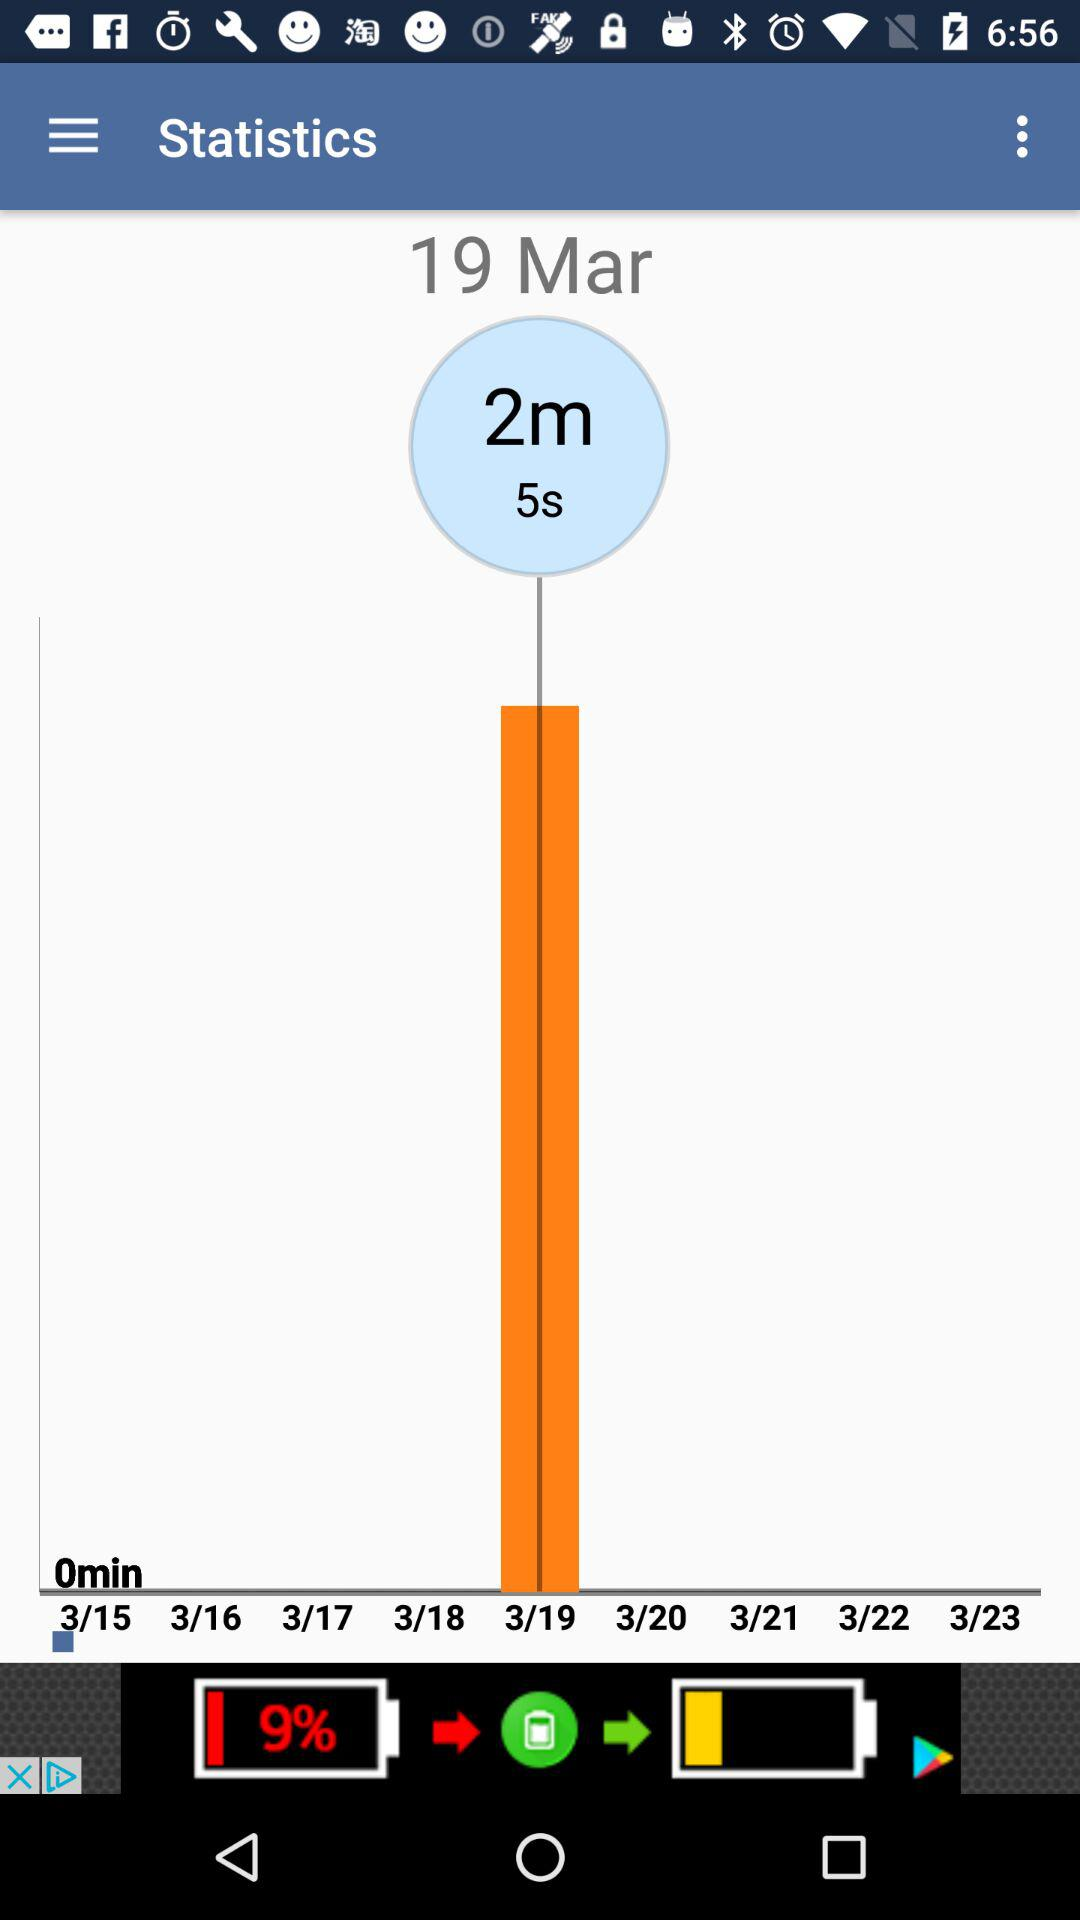How many minutes is the longest time spent on this screen?
Answer the question using a single word or phrase. 2m 